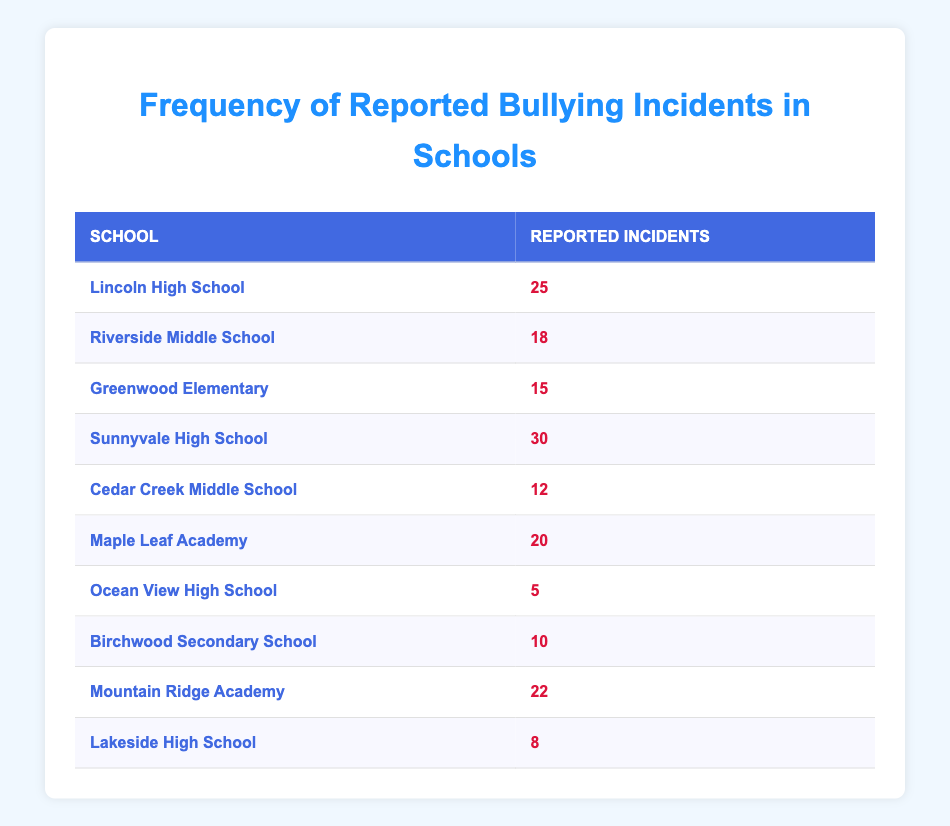What is the school with the highest number of reported bullying incidents? By looking at the table, we see all the schools listed with their respective reported incidents. Sunnyvale High School has 30 reported incidents, which is the highest number compared to other schools.
Answer: Sunnyvale High School How many reported bullying incidents were reported at Riverside Middle School? Riverside Middle School is listed in the table with a reported incidents count of 18.
Answer: 18 Which school has the least reported bullying incidents? In the table, Ocean View High School has the lowest count of reported incidents with only 5.
Answer: Ocean View High School What is the average number of reported bullying incidents across all the schools? To find the average, we sum up all reported incidents: 25 + 18 + 15 + 30 + 12 + 20 + 5 + 10 + 22 + 8 =  165. There are 10 schools, so the average is 165 / 10 = 16.5.
Answer: 16.5 Is it true that more than 20 incidents were reported at Maple Leaf Academy? From the table, Maple Leaf Academy has reported 20 incidents. This means it did not exceed 20, making the statement false.
Answer: False How many schools have reported incidents greater than 15? We can identify each school with more than 15 incidents from the table: Lincoln High School (25), Riverside Middle School (18), Sunnyvale High School (30), Maple Leaf Academy (20), Mountain Ridge Academy (22). Counting these gives us 5 schools.
Answer: 5 What is the difference between the highest and lowest reported bullying incidents? The highest reported incidents is from Sunnyvale High School with 30 incidents, and the lowest is from Ocean View High School with 5 incidents. The difference is 30 - 5 = 25.
Answer: 25 Are there any schools that reported exactly 10 incidents? Looking at the table, Birchwood Secondary School reported exactly 10 incidents. Hence, the statement is true.
Answer: True 